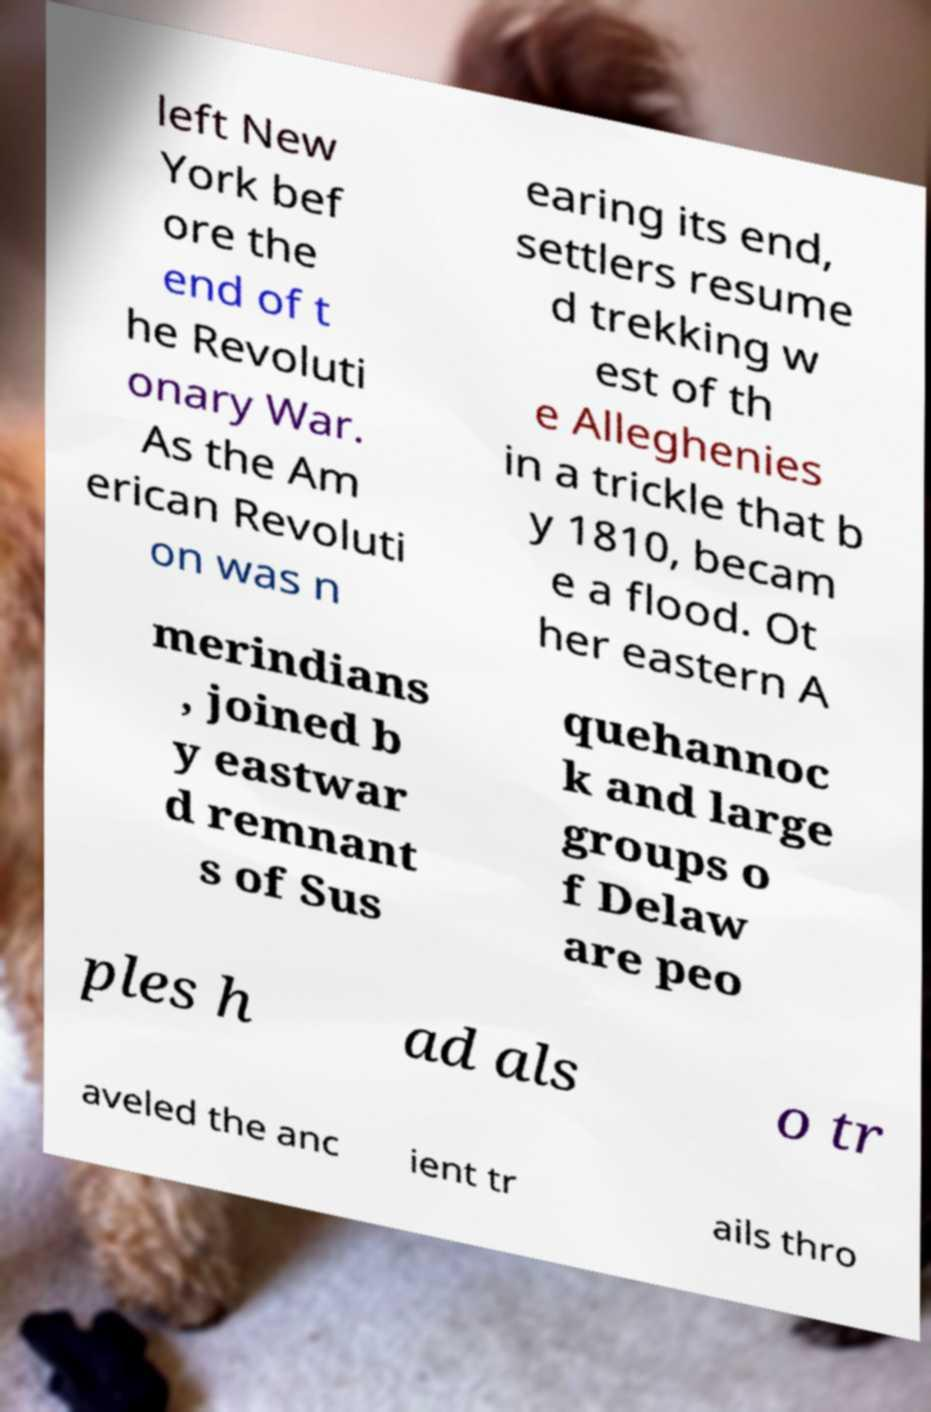There's text embedded in this image that I need extracted. Can you transcribe it verbatim? left New York bef ore the end of t he Revoluti onary War. As the Am erican Revoluti on was n earing its end, settlers resume d trekking w est of th e Alleghenies in a trickle that b y 1810, becam e a flood. Ot her eastern A merindians , joined b y eastwar d remnant s of Sus quehannoc k and large groups o f Delaw are peo ples h ad als o tr aveled the anc ient tr ails thro 